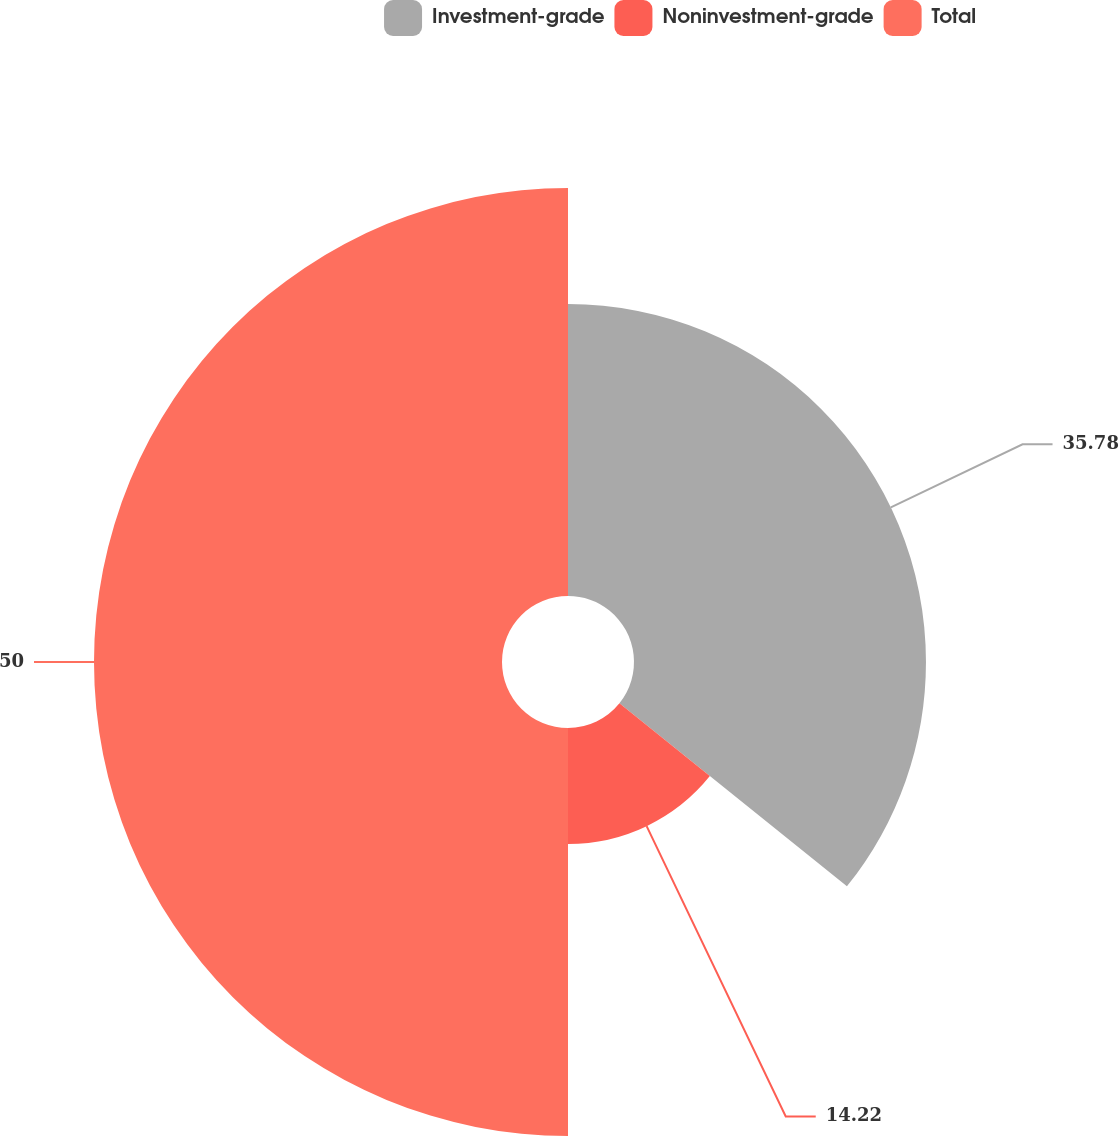Convert chart. <chart><loc_0><loc_0><loc_500><loc_500><pie_chart><fcel>Investment-grade<fcel>Noninvestment-grade<fcel>Total<nl><fcel>35.78%<fcel>14.22%<fcel>50.0%<nl></chart> 